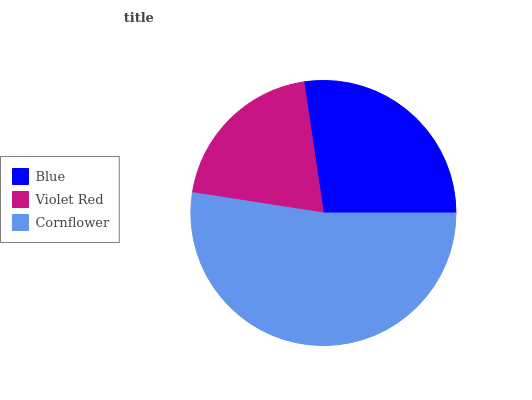Is Violet Red the minimum?
Answer yes or no. Yes. Is Cornflower the maximum?
Answer yes or no. Yes. Is Cornflower the minimum?
Answer yes or no. No. Is Violet Red the maximum?
Answer yes or no. No. Is Cornflower greater than Violet Red?
Answer yes or no. Yes. Is Violet Red less than Cornflower?
Answer yes or no. Yes. Is Violet Red greater than Cornflower?
Answer yes or no. No. Is Cornflower less than Violet Red?
Answer yes or no. No. Is Blue the high median?
Answer yes or no. Yes. Is Blue the low median?
Answer yes or no. Yes. Is Violet Red the high median?
Answer yes or no. No. Is Violet Red the low median?
Answer yes or no. No. 